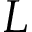<formula> <loc_0><loc_0><loc_500><loc_500>L</formula> 